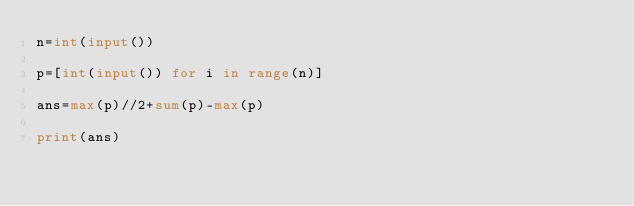<code> <loc_0><loc_0><loc_500><loc_500><_Python_>n=int(input())

p=[int(input()) for i in range(n)]

ans=max(p)//2+sum(p)-max(p)

print(ans)</code> 